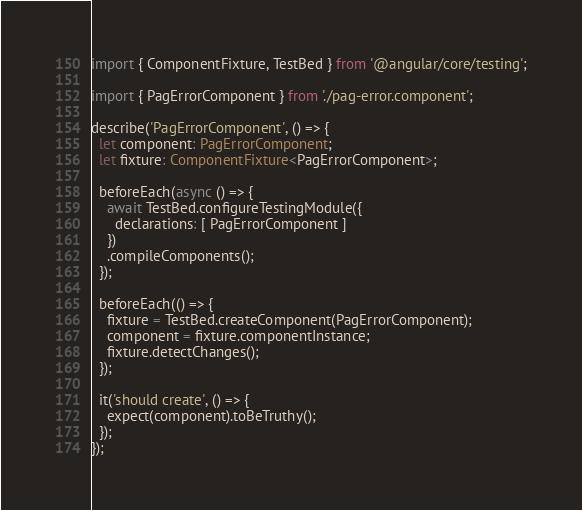<code> <loc_0><loc_0><loc_500><loc_500><_TypeScript_>import { ComponentFixture, TestBed } from '@angular/core/testing';

import { PagErrorComponent } from './pag-error.component';

describe('PagErrorComponent', () => {
  let component: PagErrorComponent;
  let fixture: ComponentFixture<PagErrorComponent>;

  beforeEach(async () => {
    await TestBed.configureTestingModule({
      declarations: [ PagErrorComponent ]
    })
    .compileComponents();
  });

  beforeEach(() => {
    fixture = TestBed.createComponent(PagErrorComponent);
    component = fixture.componentInstance;
    fixture.detectChanges();
  });

  it('should create', () => {
    expect(component).toBeTruthy();
  });
});
</code> 